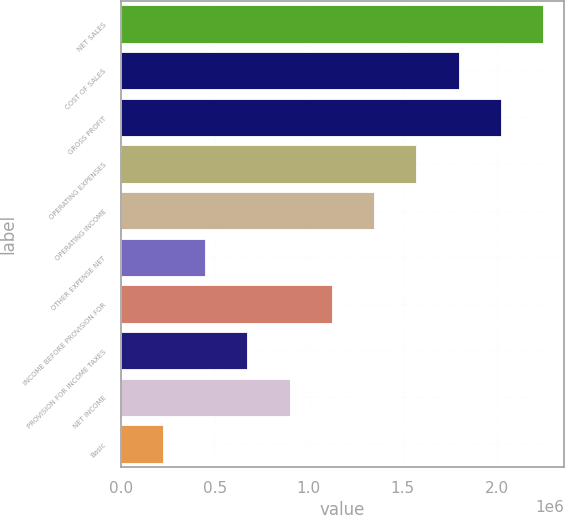Convert chart to OTSL. <chart><loc_0><loc_0><loc_500><loc_500><bar_chart><fcel>NET SALES<fcel>COST OF SALES<fcel>GROSS PROFIT<fcel>OPERATING EXPENSES<fcel>OPERATING INCOME<fcel>OTHER EXPENSE NET<fcel>INCOME BEFORE PROVISION FOR<fcel>PROVISION FOR INCOME TAXES<fcel>NET INCOME<fcel>Basic<nl><fcel>2.24643e+06<fcel>1.79714e+06<fcel>2.02179e+06<fcel>1.5725e+06<fcel>1.34786e+06<fcel>449287<fcel>1.12321e+06<fcel>673930<fcel>898572<fcel>224645<nl></chart> 